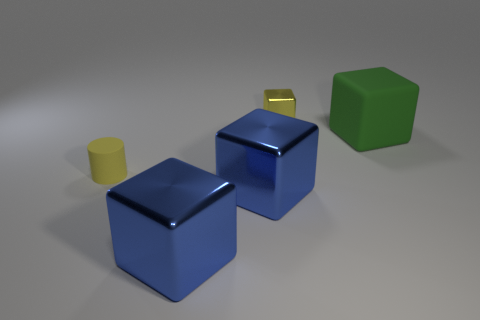Is there anything else that is the same color as the large rubber cube?
Keep it short and to the point. No. There is a small shiny object that is the same color as the rubber cylinder; what shape is it?
Provide a succinct answer. Cube. Does the matte object on the right side of the small metal block have the same shape as the yellow object that is behind the big green matte object?
Ensure brevity in your answer.  Yes. There is a tiny yellow object that is right of the yellow object that is in front of the cube that is behind the green rubber cube; what is it made of?
Your response must be concise. Metal. What shape is the thing that is the same size as the rubber cylinder?
Make the answer very short. Cube. Is there a small cylinder of the same color as the tiny shiny object?
Your answer should be compact. Yes. The green object has what size?
Offer a terse response. Large. Do the big green cube and the small yellow block have the same material?
Offer a terse response. No. There is a block that is behind the rubber thing that is behind the small yellow matte thing; how many tiny yellow metallic cubes are behind it?
Give a very brief answer. 0. What shape is the matte object that is in front of the green rubber block?
Provide a short and direct response. Cylinder. 